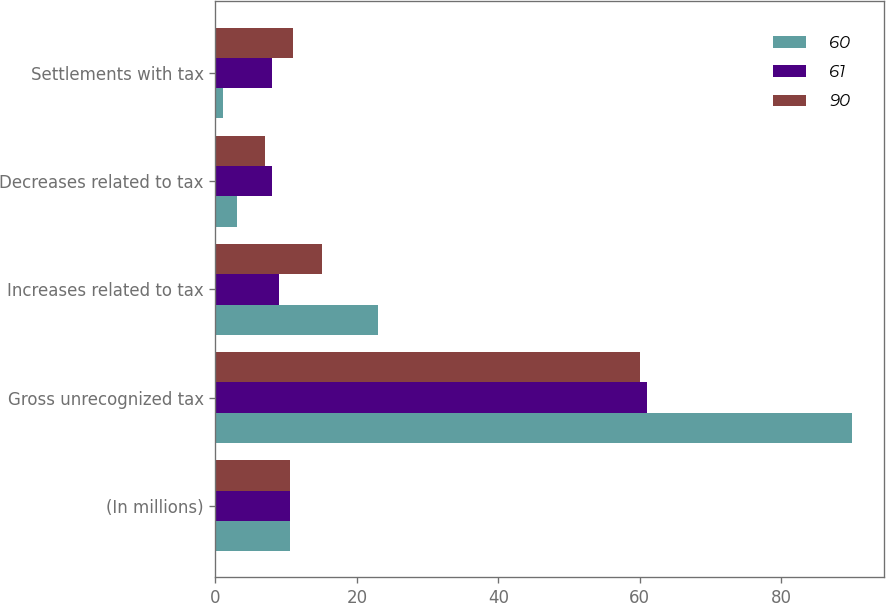<chart> <loc_0><loc_0><loc_500><loc_500><stacked_bar_chart><ecel><fcel>(In millions)<fcel>Gross unrecognized tax<fcel>Increases related to tax<fcel>Decreases related to tax<fcel>Settlements with tax<nl><fcel>60<fcel>10.5<fcel>90<fcel>23<fcel>3<fcel>1<nl><fcel>61<fcel>10.5<fcel>61<fcel>9<fcel>8<fcel>8<nl><fcel>90<fcel>10.5<fcel>60<fcel>15<fcel>7<fcel>11<nl></chart> 